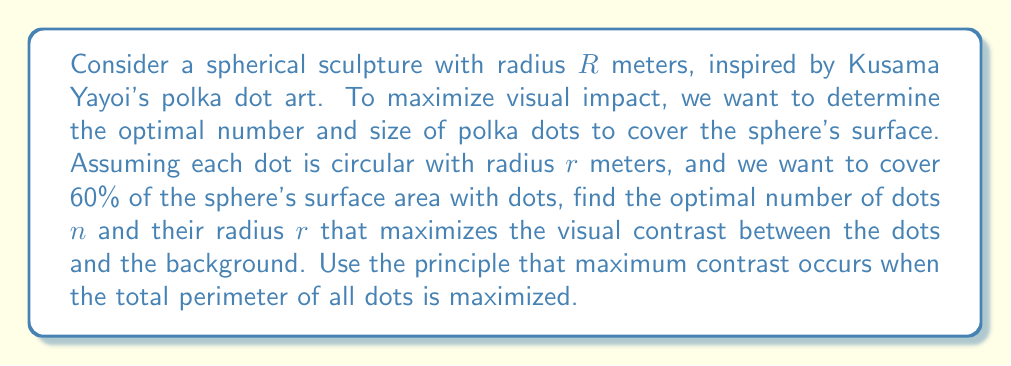Can you solve this math problem? Let's approach this step-by-step:

1) The surface area of a sphere is given by $A = 4\pi R^2$.

2) We want to cover 60% of this area with dots, so the total area of dots should be:
   $A_{dots} = 0.6 \cdot 4\pi R^2 = 2.4\pi R^2$

3) The area of each dot is $\pi r^2$, so the number of dots $n$ is:
   $n = \frac{A_{dots}}{\pi r^2} = \frac{2.4\pi R^2}{\pi r^2} = \frac{2.4R^2}{r^2}$

4) The perimeter of each dot is $2\pi r$, so the total perimeter $P$ of all dots is:
   $P = 2\pi r \cdot n = 2\pi r \cdot \frac{2.4R^2}{r^2} = \frac{4.8\pi R^2}{r}$

5) To maximize the perimeter (and thus the contrast), we need to minimize $r$. However, there's a practical limit to how small $r$ can be.

6) Let's assume the minimum visible dot size is 1% of the sphere's radius. So $r_{min} = 0.01R$.

7) Substituting this into our equations:
   $n_{max} = \frac{2.4R^2}{(0.01R)^2} = 24,000$
   $P_{max} = \frac{4.8\pi R^2}{0.01R} = 480\pi R$

Therefore, the optimal configuration is to use the smallest practical dot size, which in this case is $r = 0.01R$, and the corresponding number of dots is 24,000.
Answer: $r = 0.01R$, $n = 24,000$ 